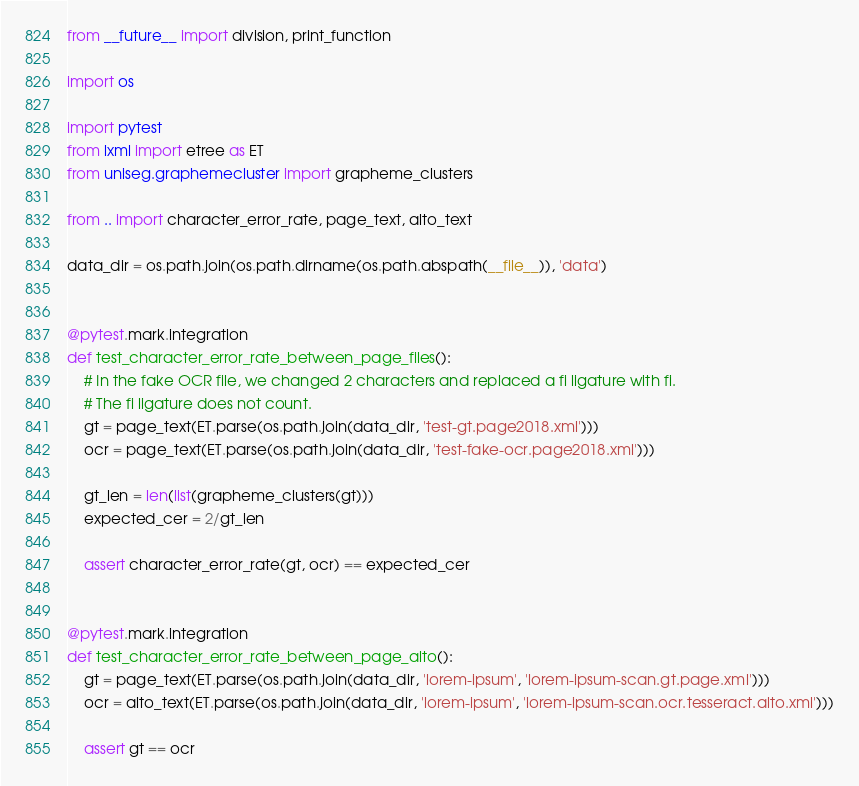<code> <loc_0><loc_0><loc_500><loc_500><_Python_>from __future__ import division, print_function

import os

import pytest
from lxml import etree as ET
from uniseg.graphemecluster import grapheme_clusters

from .. import character_error_rate, page_text, alto_text

data_dir = os.path.join(os.path.dirname(os.path.abspath(__file__)), 'data')


@pytest.mark.integration
def test_character_error_rate_between_page_files():
    # In the fake OCR file, we changed 2 characters and replaced a fi ligature with fi.
    # The fi ligature does not count.
    gt = page_text(ET.parse(os.path.join(data_dir, 'test-gt.page2018.xml')))
    ocr = page_text(ET.parse(os.path.join(data_dir, 'test-fake-ocr.page2018.xml')))

    gt_len = len(list(grapheme_clusters(gt)))
    expected_cer = 2/gt_len

    assert character_error_rate(gt, ocr) == expected_cer


@pytest.mark.integration
def test_character_error_rate_between_page_alto():
    gt = page_text(ET.parse(os.path.join(data_dir, 'lorem-ipsum', 'lorem-ipsum-scan.gt.page.xml')))
    ocr = alto_text(ET.parse(os.path.join(data_dir, 'lorem-ipsum', 'lorem-ipsum-scan.ocr.tesseract.alto.xml')))

    assert gt == ocr</code> 